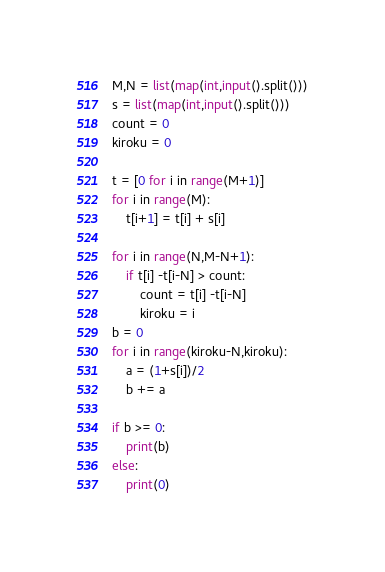Convert code to text. <code><loc_0><loc_0><loc_500><loc_500><_Python_>M,N = list(map(int,input().split()))
s = list(map(int,input().split()))
count = 0
kiroku = 0

t = [0 for i in range(M+1)]
for i in range(M):
    t[i+1] = t[i] + s[i]

for i in range(N,M-N+1):
    if t[i] -t[i-N] > count:
        count = t[i] -t[i-N]
        kiroku = i
b = 0
for i in range(kiroku-N,kiroku):
    a = (1+s[i])/2
    b += a

if b >= 0:
    print(b)
else:
    print(0)</code> 